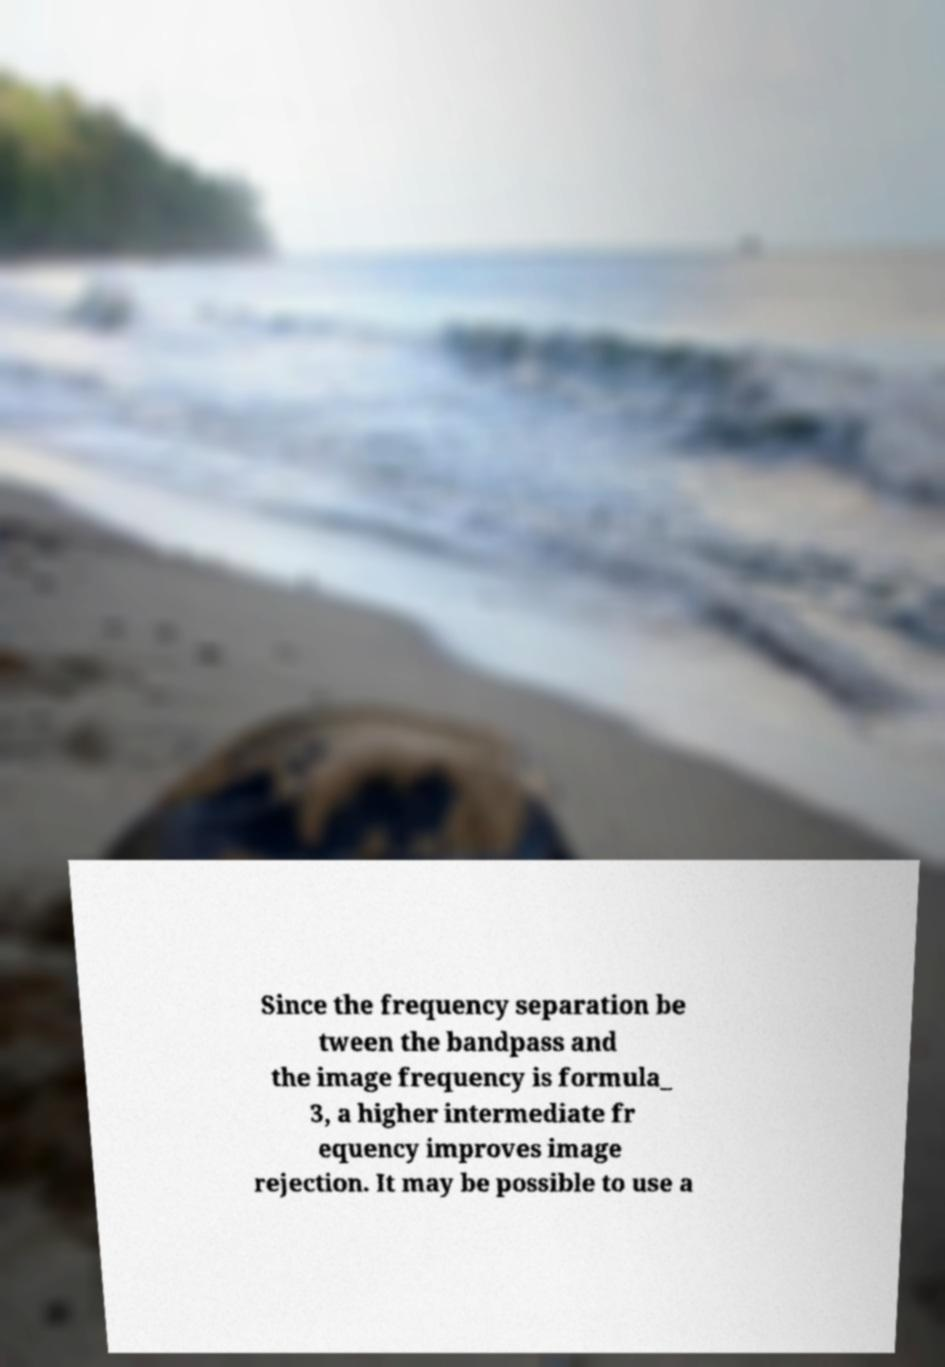Can you read and provide the text displayed in the image?This photo seems to have some interesting text. Can you extract and type it out for me? Since the frequency separation be tween the bandpass and the image frequency is formula_ 3, a higher intermediate fr equency improves image rejection. It may be possible to use a 